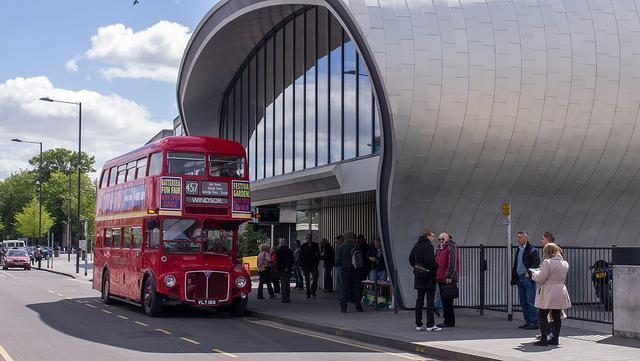How many levels are in this bus?
Give a very brief answer. 2. How many buses can you see?
Give a very brief answer. 1. How many people can be seen?
Give a very brief answer. 2. How many blue trains can you see?
Give a very brief answer. 0. 